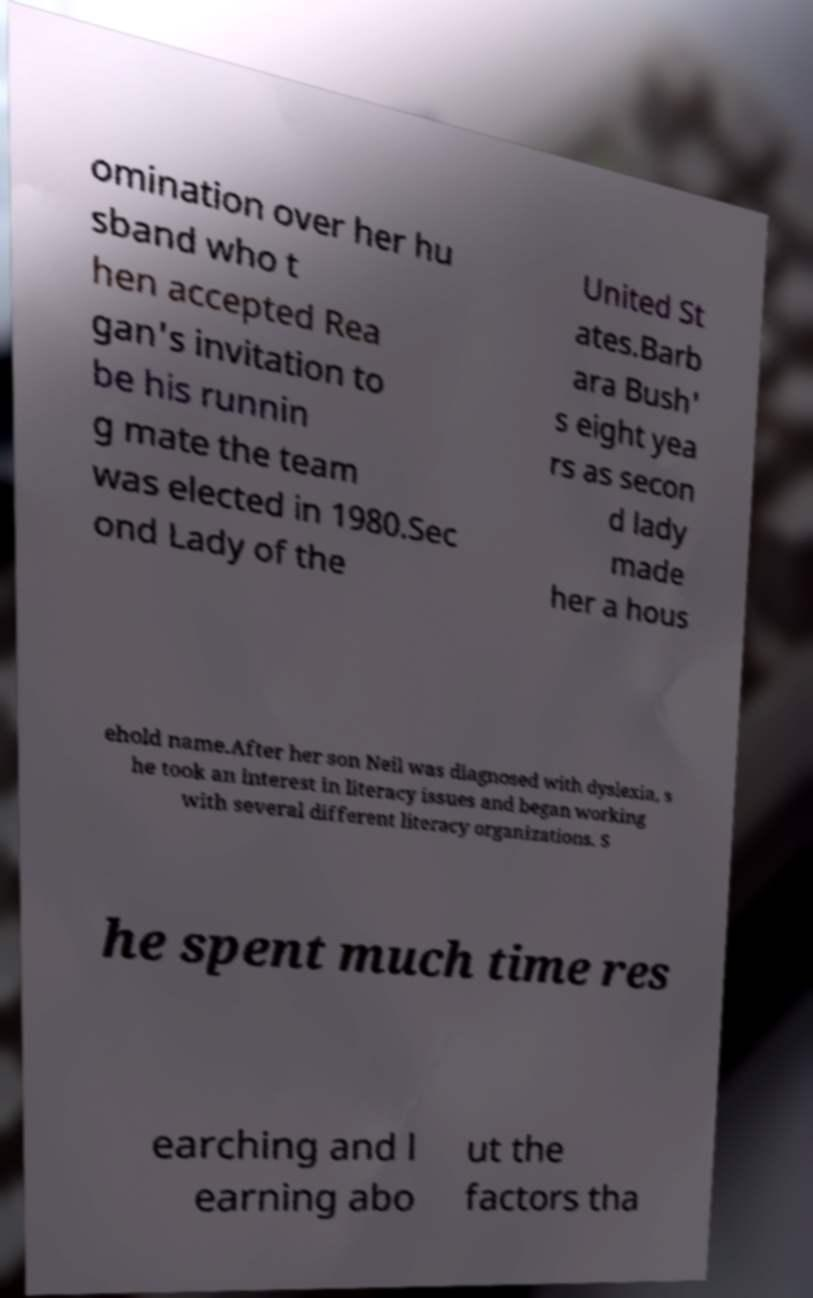There's text embedded in this image that I need extracted. Can you transcribe it verbatim? omination over her hu sband who t hen accepted Rea gan's invitation to be his runnin g mate the team was elected in 1980.Sec ond Lady of the United St ates.Barb ara Bush' s eight yea rs as secon d lady made her a hous ehold name.After her son Neil was diagnosed with dyslexia, s he took an interest in literacy issues and began working with several different literacy organizations. S he spent much time res earching and l earning abo ut the factors tha 